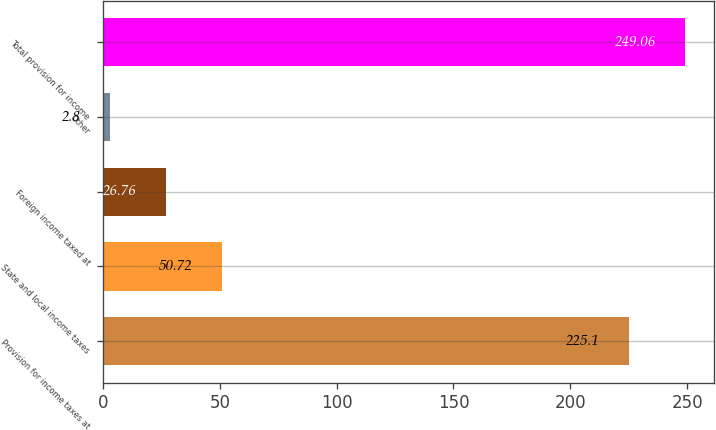<chart> <loc_0><loc_0><loc_500><loc_500><bar_chart><fcel>Provision for income taxes at<fcel>State and local income taxes<fcel>Foreign income taxed at<fcel>Other<fcel>Total provision for income<nl><fcel>225.1<fcel>50.72<fcel>26.76<fcel>2.8<fcel>249.06<nl></chart> 